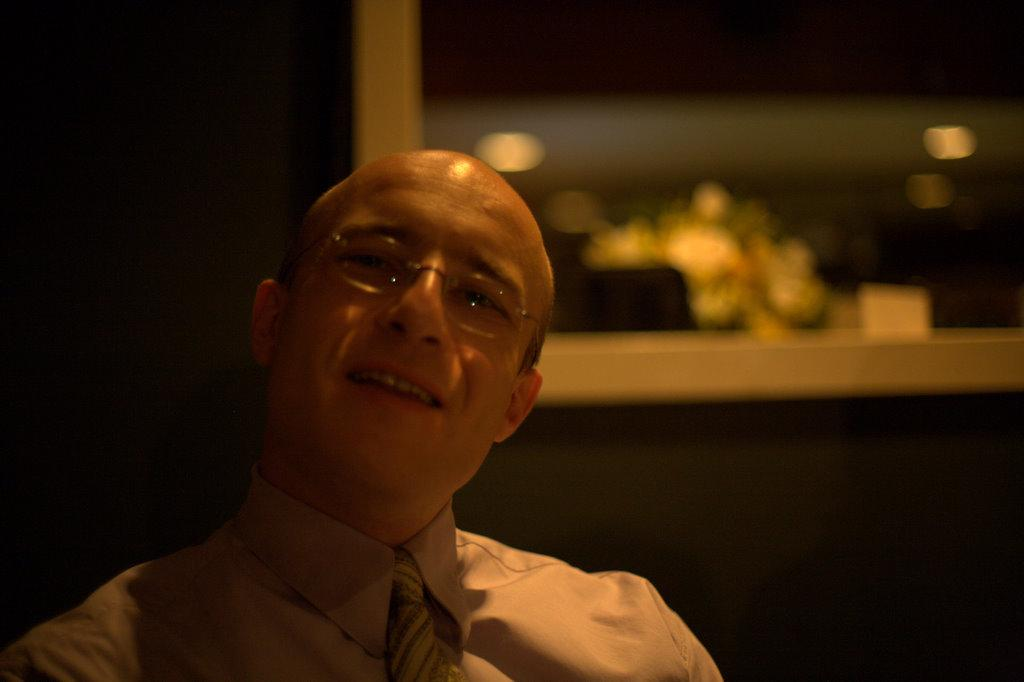What is the man in the image doing? The man is sitting in the image. What is the man's facial expression? The man is smiling. What accessory is the man wearing? The man is wearing spectacles. What can be seen in the background of the image? There is a window in the background of the image. What is visible through the window? There are lights visible from the window. What type of help can be seen being offered in the image? There is no indication of help being offered in the image. 